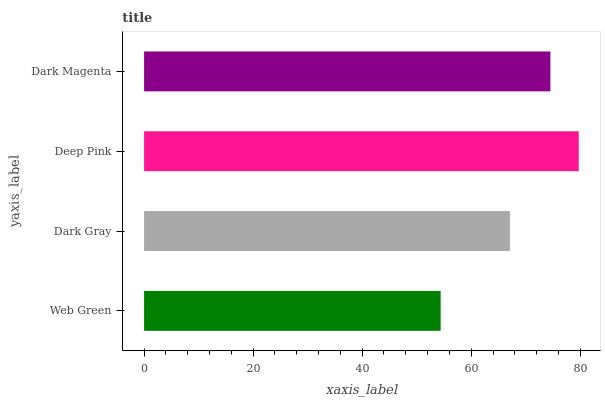Is Web Green the minimum?
Answer yes or no. Yes. Is Deep Pink the maximum?
Answer yes or no. Yes. Is Dark Gray the minimum?
Answer yes or no. No. Is Dark Gray the maximum?
Answer yes or no. No. Is Dark Gray greater than Web Green?
Answer yes or no. Yes. Is Web Green less than Dark Gray?
Answer yes or no. Yes. Is Web Green greater than Dark Gray?
Answer yes or no. No. Is Dark Gray less than Web Green?
Answer yes or no. No. Is Dark Magenta the high median?
Answer yes or no. Yes. Is Dark Gray the low median?
Answer yes or no. Yes. Is Dark Gray the high median?
Answer yes or no. No. Is Web Green the low median?
Answer yes or no. No. 